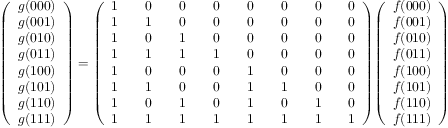Convert formula to latex. <formula><loc_0><loc_0><loc_500><loc_500>{ \left ( \begin{array} { l } { g ( 0 0 0 ) } \\ { g ( 0 0 1 ) } \\ { g ( 0 1 0 ) } \\ { g ( 0 1 1 ) } \\ { g ( 1 0 0 ) } \\ { g ( 1 0 1 ) } \\ { g ( 1 1 0 ) } \\ { g ( 1 1 1 ) } \end{array} \right ) } = { \left ( \begin{array} { l l l l l l l l l l l l l l l } { 1 } & & { 0 } & & { 0 } & & { 0 } & & { 0 } & & { 0 } & & { 0 } & & { 0 } \\ { 1 } & & { 1 } & & { 0 } & & { 0 } & & { 0 } & & { 0 } & & { 0 } & & { 0 } \\ { 1 } & & { 0 } & & { 1 } & & { 0 } & & { 0 } & & { 0 } & & { 0 } & & { 0 } \\ { 1 } & & { 1 } & & { 1 } & & { 1 } & & { 0 } & & { 0 } & & { 0 } & & { 0 } \\ { 1 } & & { 0 } & & { 0 } & & { 0 } & & { 1 } & & { 0 } & & { 0 } & & { 0 } \\ { 1 } & & { 1 } & & { 0 } & & { 0 } & & { 1 } & & { 1 } & & { 0 } & & { 0 } \\ { 1 } & & { 0 } & & { 1 } & & { 0 } & & { 1 } & & { 0 } & & { 1 } & & { 0 } \\ { 1 } & & { 1 } & & { 1 } & & { 1 } & & { 1 } & & { 1 } & & { 1 } & & { 1 } \end{array} \right ) } { \left ( \begin{array} { l } { f ( 0 0 0 ) } \\ { f ( 0 0 1 ) } \\ { f ( 0 1 0 ) } \\ { f ( 0 1 1 ) } \\ { f ( 1 0 0 ) } \\ { f ( 1 0 1 ) } \\ { f ( 1 1 0 ) } \\ { f ( 1 1 1 ) } \end{array} \right ) }</formula> 